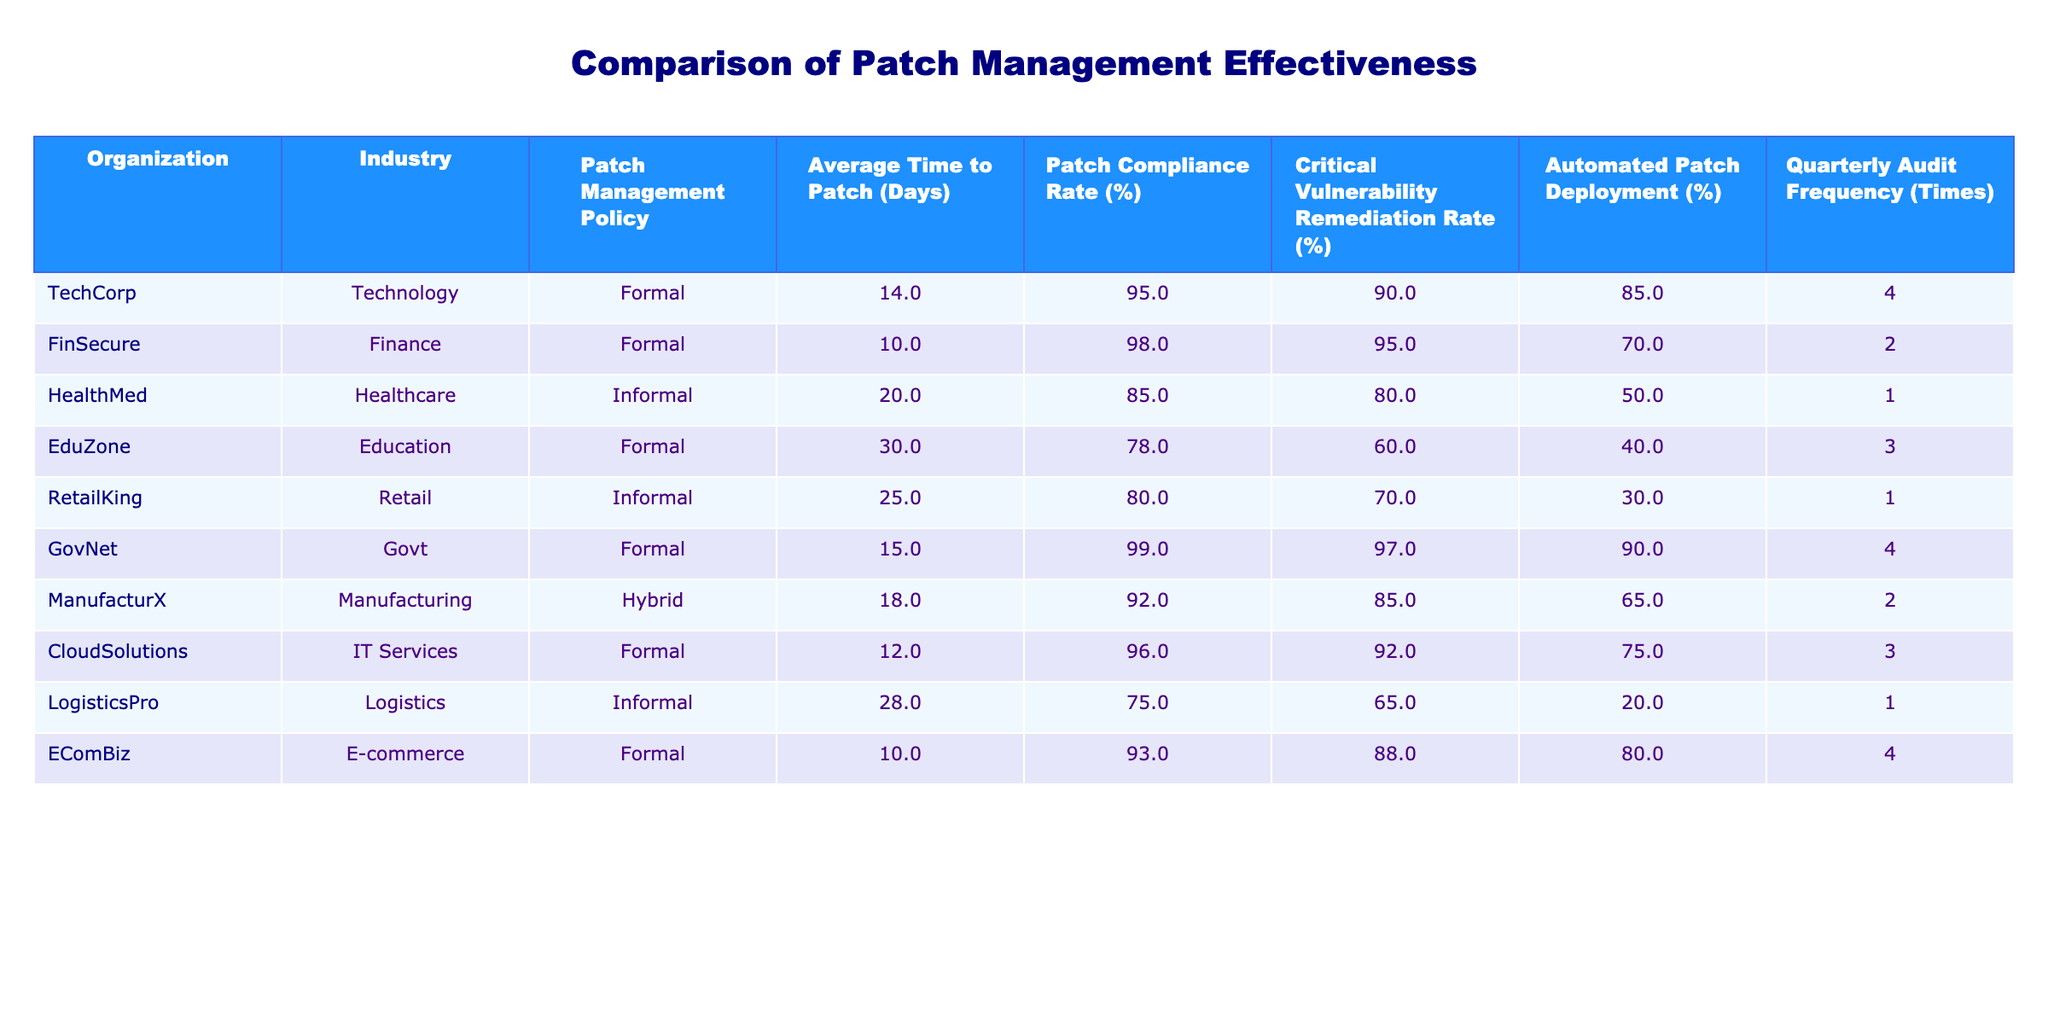What is the average time to patch across all organizations? To find the average time to patch, sum the values of "Average Time to Patch (Days)" for all organizations: 14 + 10 + 20 + 30 + 25 + 15 + 18 + 12 + 28 + 10 =  172. There are 10 organizations, so the average is 172 / 10 = 17.2 days.
Answer: 17.2 days Which organization has the highest patch compliance rate? By examining the "Patch Compliance Rate (%)" column, we can find that GovNet has the highest value at 99%.
Answer: GovNet Is there any organization with an informal patch management policy that has a patch compliance rate above 80%? Checking the "Patch Compliance Rate (%)" for organizations with an informal policy, RetailKing (80%) and HealthMed (85%) are both below or equal to 80%. Thus, there are no organizations that meet this criteria.
Answer: No How does the average time to patch for formal policies compare to informal policies? Calculate the average for formal policies: (14 + 10 + 30 + 15 + 12 + 10) / 6 = 13.5 days. For informal policies: (20 + 25 + 28) / 3 = 24.3 days. Formal patches are faster than informal ones.
Answer: Formal policies are faster What percentage of organizations have implemented automated patch deployment above 70%? Out of 10 organizations, FinSecure, GovNet, EComBiz, and CloudSolutions have automated patch deployment percentages above 70%. This is 4 out of 10 or 40%.
Answer: 40% Is the critical vulnerability remediation rate of TechCorp higher than that of HealthMed? TechCorp has a critical vulnerability remediation rate of 90%, while HealthMed has 80%. Since 90% is higher than 80%, the answer is yes.
Answer: Yes What is the difference in critical vulnerability remediation rates between the organization with the highest and the lowest rates? The highest rate is GovNet at 97% and the lowest is LogisticsPro at 65%. The difference is 97 - 65 = 32%.
Answer: 32% Which organization in the education sector has the longest average time to patch? The organization in the education sector is EduZone, which has an average time to patch of 30 days.
Answer: EduZone Is there a correlation between quarterly audit frequency and patch compliance rates? By analyzing the data, the organizations with higher audit frequency (GovNet, TechCorp, EComBiz) have higher patch compliance rates, indicating a positive correlation overall, but a detailed statistical analysis would provide more clarity.
Answer: Yes, a positive correlation 